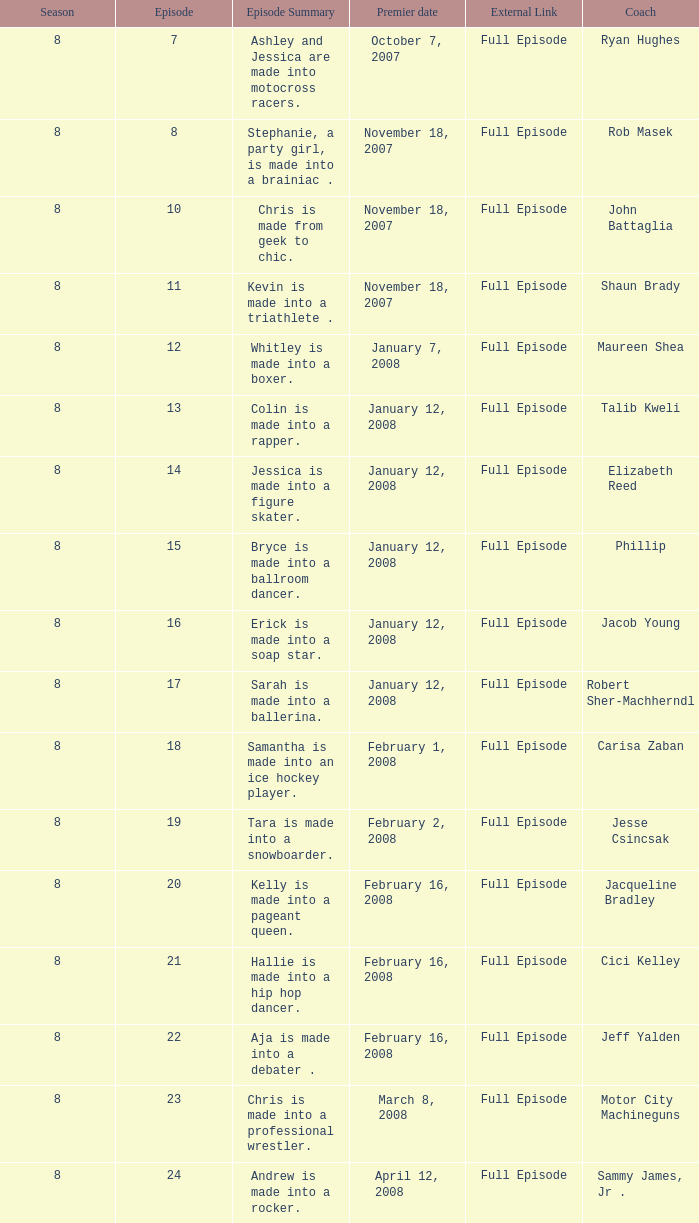In episode 15, who was the mentor? Phillip. 